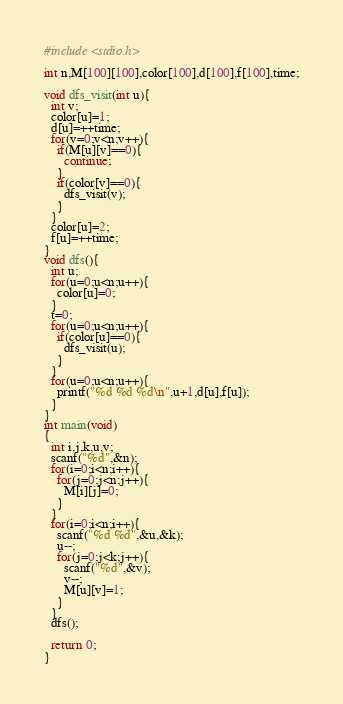<code> <loc_0><loc_0><loc_500><loc_500><_C_>#include <stdio.h>

int n,M[100][100],color[100],d[100],f[100],time;

void dfs_visit(int u){
  int v;
  color[u]=1;
  d[u]=++time;
  for(v=0;v<n;v++){
    if(M[u][v]==0){
      continue;
    }
    if(color[v]==0){
      dfs_visit(v);
    }
  }
  color[u]=2;
  f[u]=++time;
}
void dfs(){
  int u;
  for(u=0;u<n;u++){
    color[u]=0;
  }
  t=0;
  for(u=0;u<n;u++){
    if(color[u]==0){
      dfs_visit(u);
    }
  }
  for(u=0;u<n;u++){
    printf("%d %d %d\n",u+1,d[u],f[u]);
  }
}
int main(void)
{
  int i,j,k,u,v;
  scanf("%d",&n);
  for(i=0;i<n;i++){
    for(j=0;j<n;j++){
      M[i][j]=0;
    }
  }
  for(i=0;i<n;i++){
    scanf("%d %d",&u,&k);
    u--;
    for(j=0;j<k;j++){
      scanf("%d",&v);
      v--;
      M[u][v]=1;
    }
  }
  dfs();

  return 0;
}</code> 